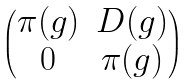<formula> <loc_0><loc_0><loc_500><loc_500>\begin{pmatrix} \pi ( g ) & D ( g ) \\ 0 & \pi ( g ) \end{pmatrix}</formula> 